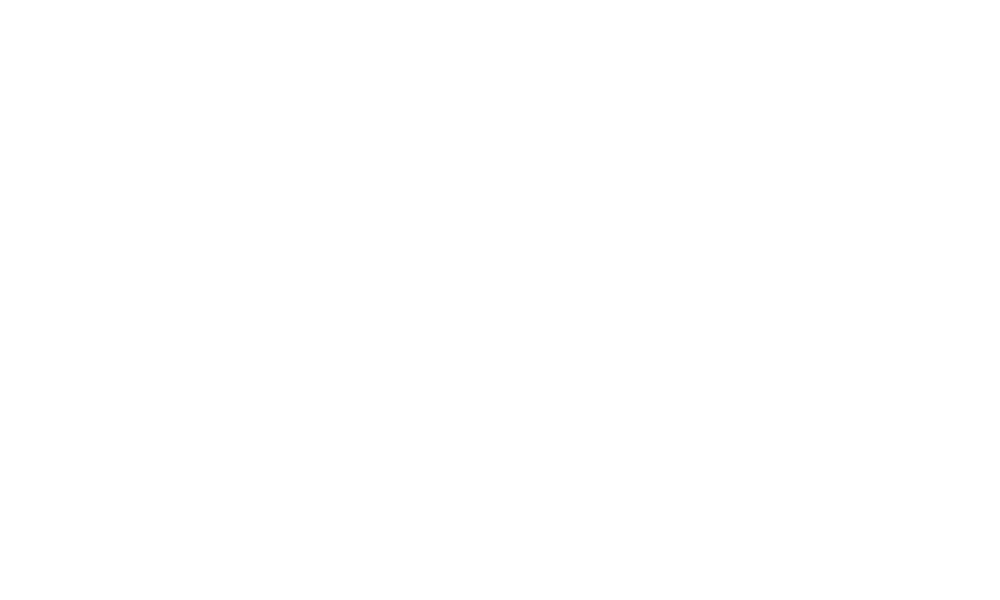Convert chart to OTSL. <chart><loc_0><loc_0><loc_500><loc_500><pie_chart><fcel>Cross currency interest rate<nl><fcel>100.0%<nl></chart> 